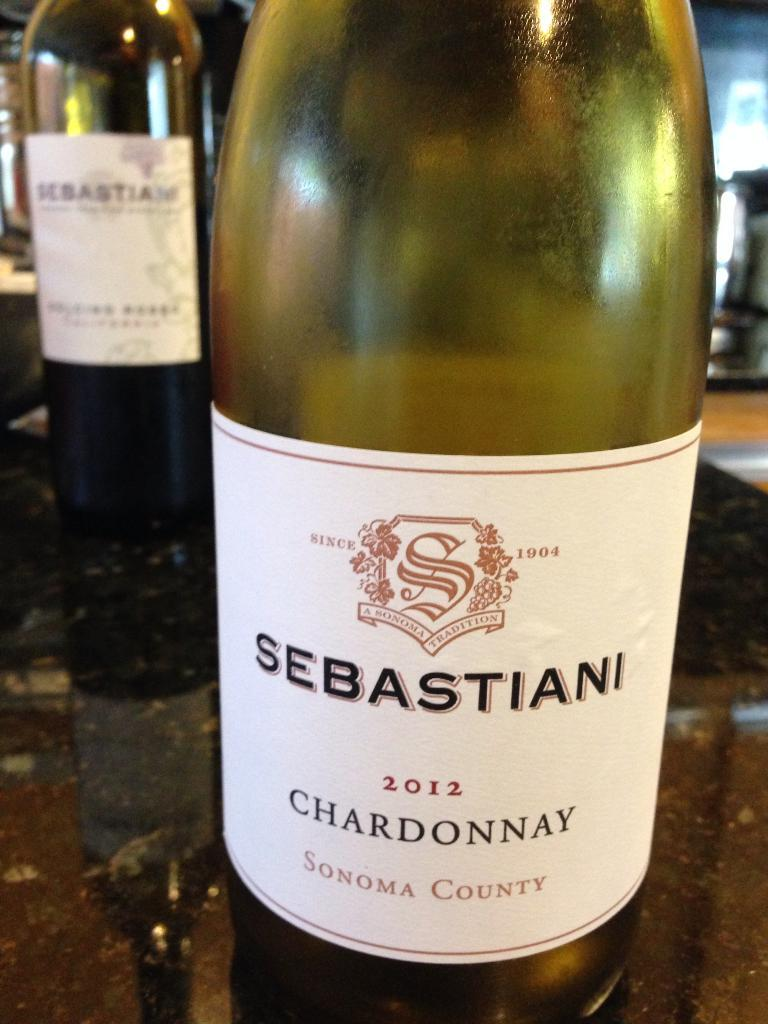<image>
Describe the image concisely. the name sebastiani that is on a wine bottle 